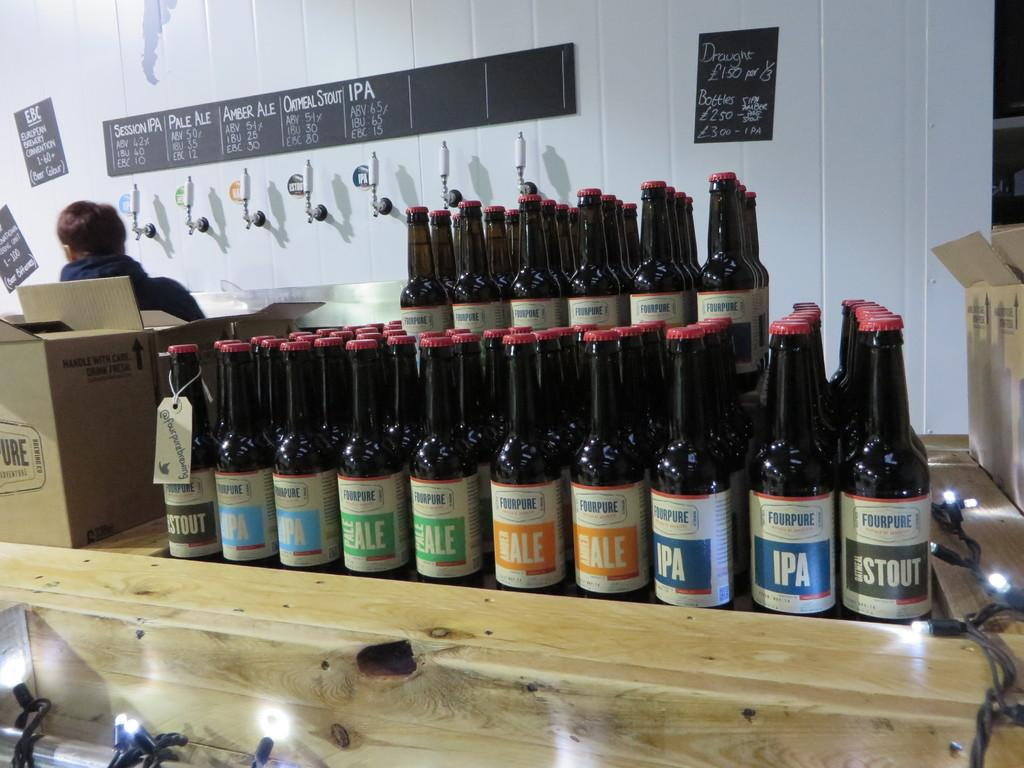<image>
Describe the image concisely. A stack of IPA and ale bottles rest on a counter. 